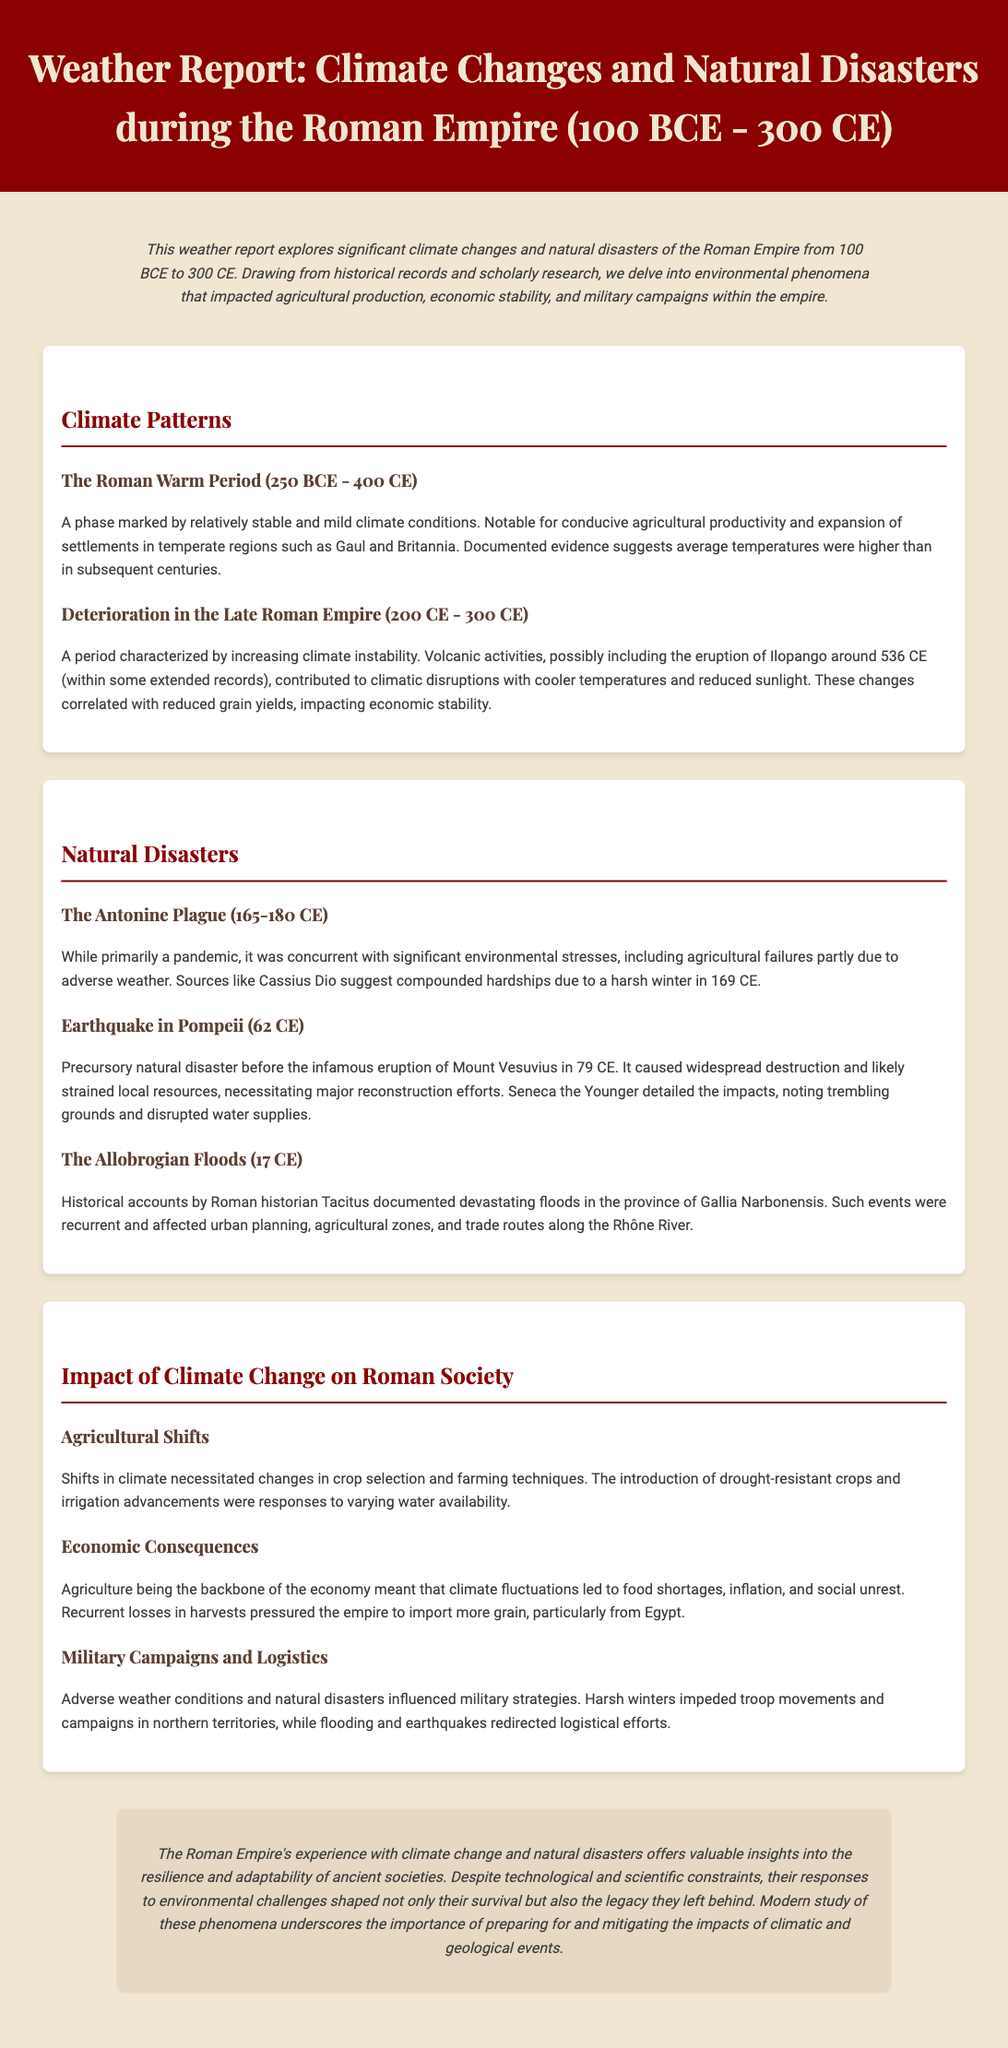what is the time period covered in the report? The report examines weather patterns and natural disasters during the Roman Empire from 100 BCE to 300 CE.
Answer: 100 BCE - 300 CE what is the title of the first section? The first section discusses climate patterns during the Roman Empire.
Answer: Climate Patterns what event occurred in 62 CE? This event refers to the earthquake in Pompeii.
Answer: Earthquake in Pompeii what were the significant climatic changes in the late Roman Empire? The late Roman Empire experienced increasing climate instability, particularly cooler temperatures and reduced sunlight.
Answer: Increasing climate instability what agricultural shift is mentioned in the report? The report indicates that shifts in climate necessitated changes in crop selection and farming techniques.
Answer: Changes in crop selection how did the Antonine Plague impact the Roman Empire? It was concurrent with significant environmental stresses, including agricultural failures due to adverse weather.
Answer: Agricultural failures what was one consequence of the Allobrogian Floods? The floods affected urban planning, agricultural zones, and trade routes along the Rhône River.
Answer: Affected urban planning what characterized the Roman Warm Period? The Roman Warm Period was marked by relatively stable and mild climate conditions conducive to agricultural productivity.
Answer: Stable and mild climate conditions what impact did military campaigns have on weather conditions? Adverse weather conditions influenced military strategies and troop movements, impacting campaigns in northern territories.
Answer: Influenced military strategies 